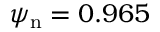<formula> <loc_0><loc_0><loc_500><loc_500>{ \psi _ { n } = 0 . 9 6 5 }</formula> 